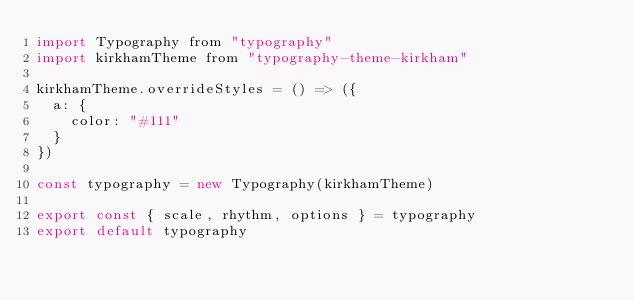<code> <loc_0><loc_0><loc_500><loc_500><_JavaScript_>import Typography from "typography"
import kirkhamTheme from "typography-theme-kirkham"

kirkhamTheme.overrideStyles = () => ({
  a: {
    color: "#111"
  }
})

const typography = new Typography(kirkhamTheme)

export const { scale, rhythm, options } = typography
export default typography</code> 